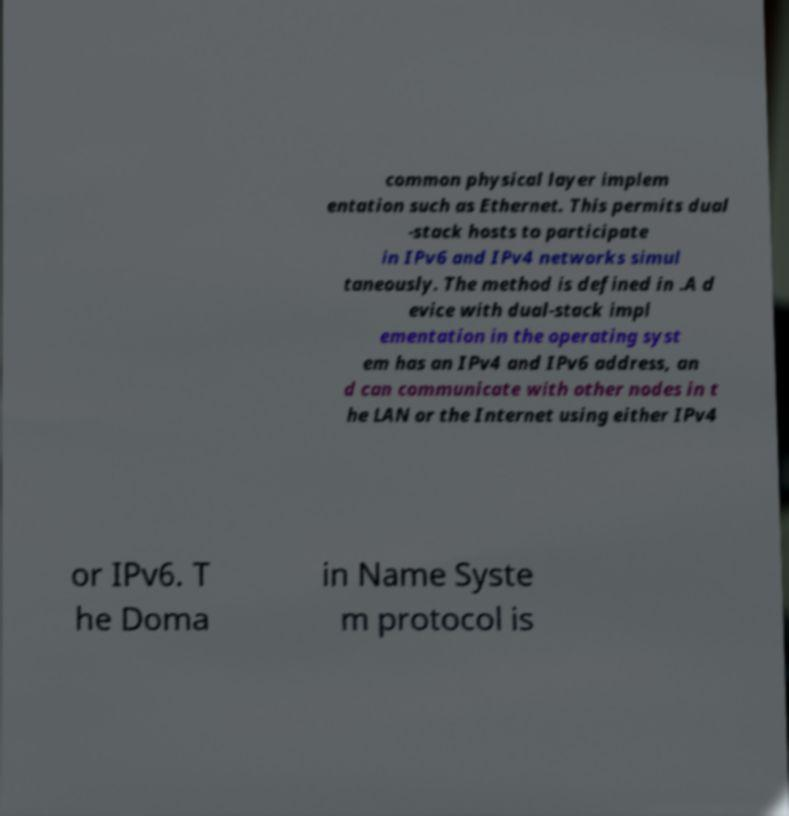Could you assist in decoding the text presented in this image and type it out clearly? common physical layer implem entation such as Ethernet. This permits dual -stack hosts to participate in IPv6 and IPv4 networks simul taneously. The method is defined in .A d evice with dual-stack impl ementation in the operating syst em has an IPv4 and IPv6 address, an d can communicate with other nodes in t he LAN or the Internet using either IPv4 or IPv6. T he Doma in Name Syste m protocol is 